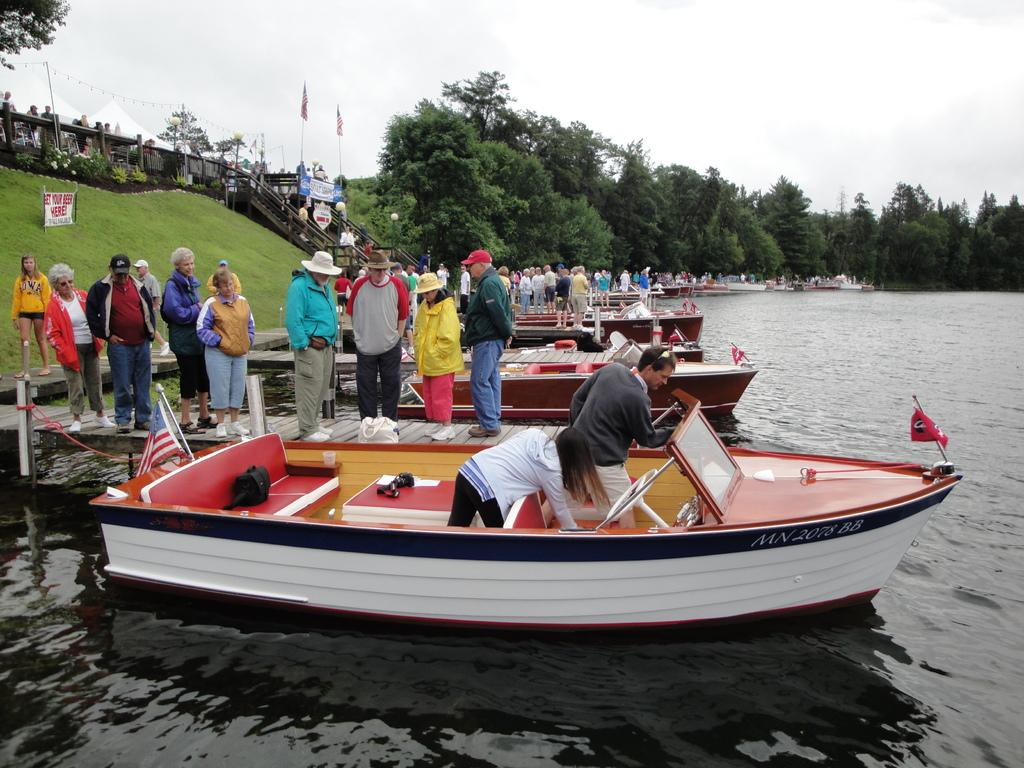<image>
Describe the image concisely. the word here is on a sign near the people in boats 